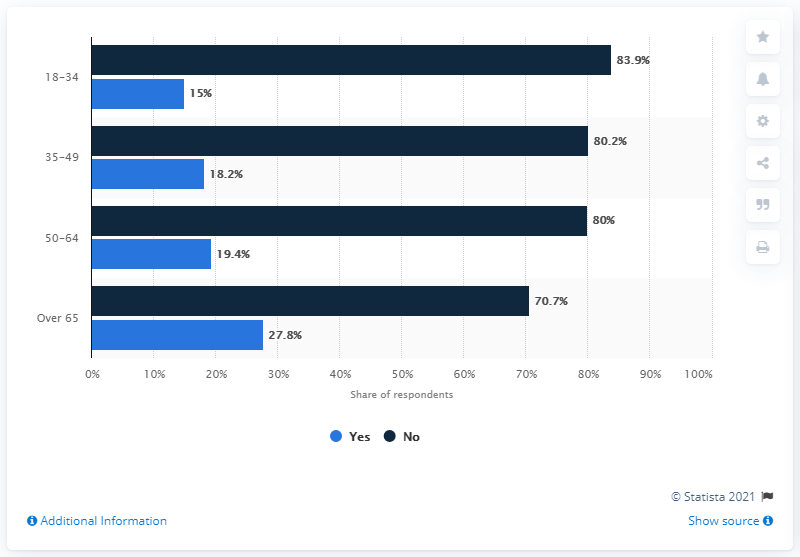Indicate a few pertinent items in this graphic. The majority of people who did not vaccinate against seasonal flu in Romania in 2019 belonged to the age group of 18-34 years old. 